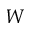<formula> <loc_0><loc_0><loc_500><loc_500>W</formula> 